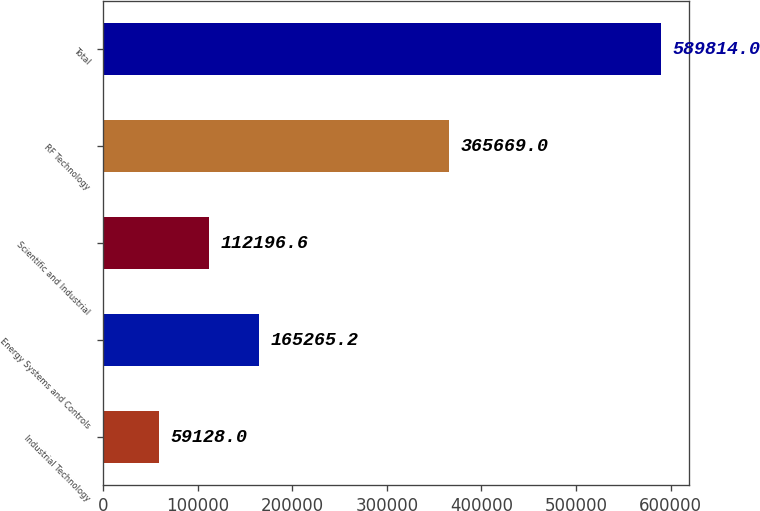Convert chart. <chart><loc_0><loc_0><loc_500><loc_500><bar_chart><fcel>Industrial Technology<fcel>Energy Systems and Controls<fcel>Scientific and Industrial<fcel>RF Technology<fcel>Total<nl><fcel>59128<fcel>165265<fcel>112197<fcel>365669<fcel>589814<nl></chart> 